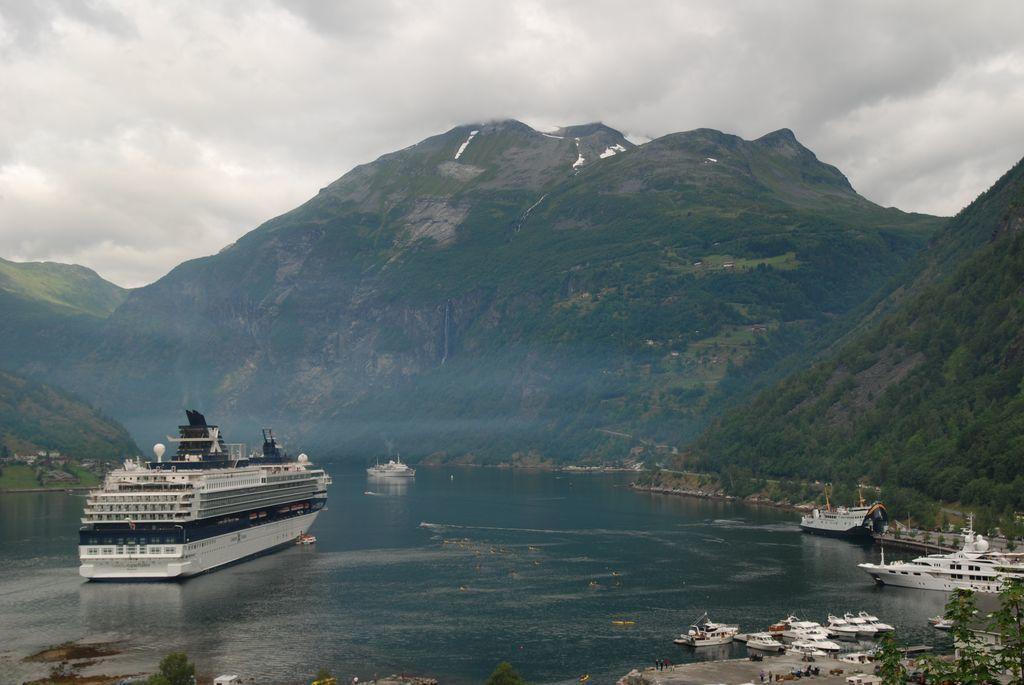Describe this image in one or two sentences. In this image at the bottom there is a river, in the river there are some boats and in the background there are some mountains and trees and grass. At the top there is sky, and in the bottom right hand corner there are some boats, plants and some objects. 